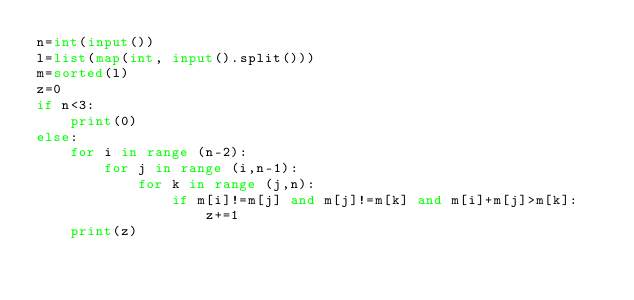Convert code to text. <code><loc_0><loc_0><loc_500><loc_500><_Python_>n=int(input())
l=list(map(int, input().split()))
m=sorted(l)
z=0
if n<3:
    print(0)
else:
    for i in range (n-2):
        for j in range (i,n-1):
            for k in range (j,n):
                if m[i]!=m[j] and m[j]!=m[k] and m[i]+m[j]>m[k]:
                    z+=1
    print(z)
</code> 